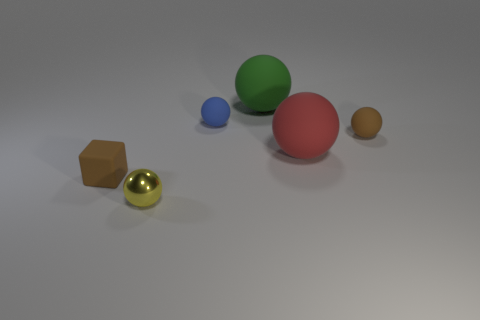What size is the rubber object that is the same color as the matte block?
Provide a short and direct response. Small. There is a large sphere that is in front of the small brown matte object that is to the right of the tiny sphere that is in front of the red rubber thing; what color is it?
Offer a terse response. Red. There is a rubber block that is the same size as the metallic thing; what color is it?
Your answer should be compact. Brown. There is a big thing behind the tiny matte sphere that is on the left side of the small brown matte object that is to the right of the yellow metal thing; what is its shape?
Give a very brief answer. Sphere. What shape is the small object that is the same color as the rubber block?
Your answer should be very brief. Sphere. How many things are either metal cylinders or matte things behind the blue object?
Offer a very short reply. 1. Is the size of the brown object that is to the right of the yellow metal ball the same as the yellow thing?
Keep it short and to the point. Yes. What is the material of the brown object to the right of the tiny yellow ball?
Provide a short and direct response. Rubber. Are there the same number of tiny metal objects left of the tiny yellow metallic object and yellow objects to the right of the small brown rubber sphere?
Offer a terse response. Yes. There is another large thing that is the same shape as the large red matte thing; what is its color?
Give a very brief answer. Green. 